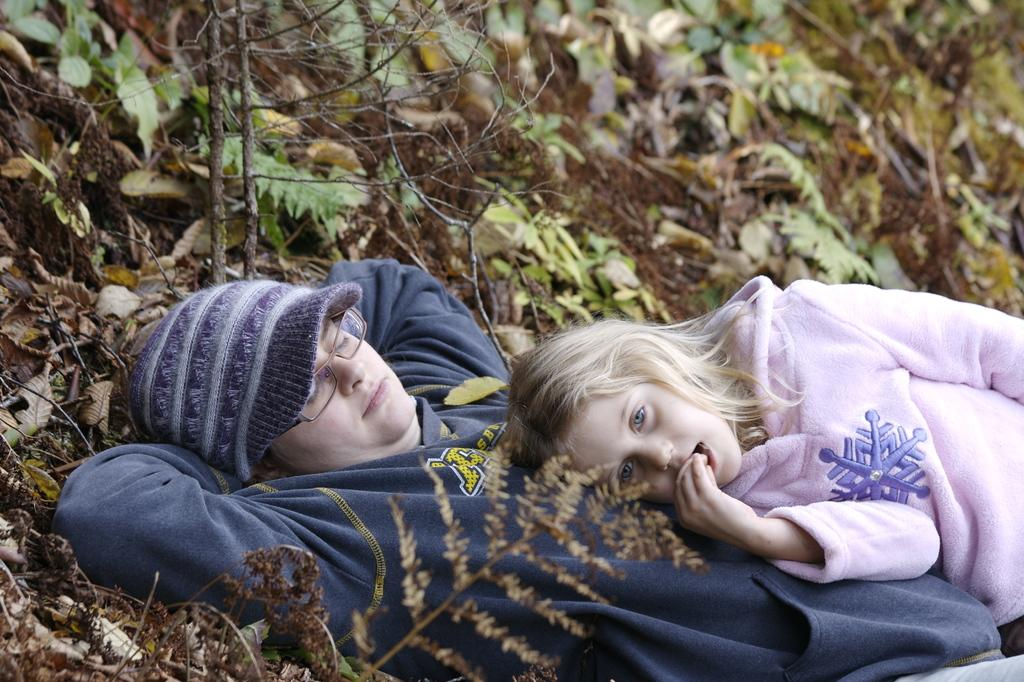What are the two persons in the image doing? The two persons are lying on the ground in the image. What type of natural elements can be seen in the image? There are leaves visible in the image, and a tree branch is also present. What type of music is the band playing in the image? There is no band present in the image, so it is not possible to determine what type of music they might be playing. 